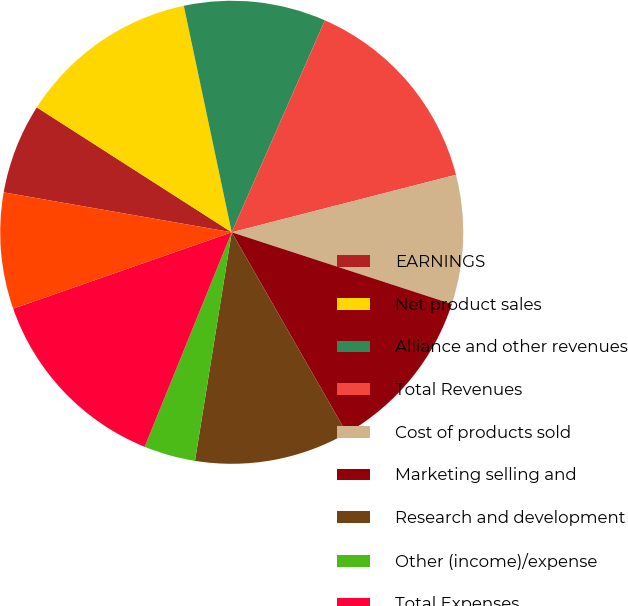Convert chart. <chart><loc_0><loc_0><loc_500><loc_500><pie_chart><fcel>EARNINGS<fcel>Net product sales<fcel>Alliance and other revenues<fcel>Total Revenues<fcel>Cost of products sold<fcel>Marketing selling and<fcel>Research and development<fcel>Other (income)/expense<fcel>Total Expenses<fcel>Earnings Before Income Taxes<nl><fcel>6.31%<fcel>12.61%<fcel>9.91%<fcel>14.41%<fcel>9.01%<fcel>11.71%<fcel>10.81%<fcel>3.6%<fcel>13.51%<fcel>8.11%<nl></chart> 